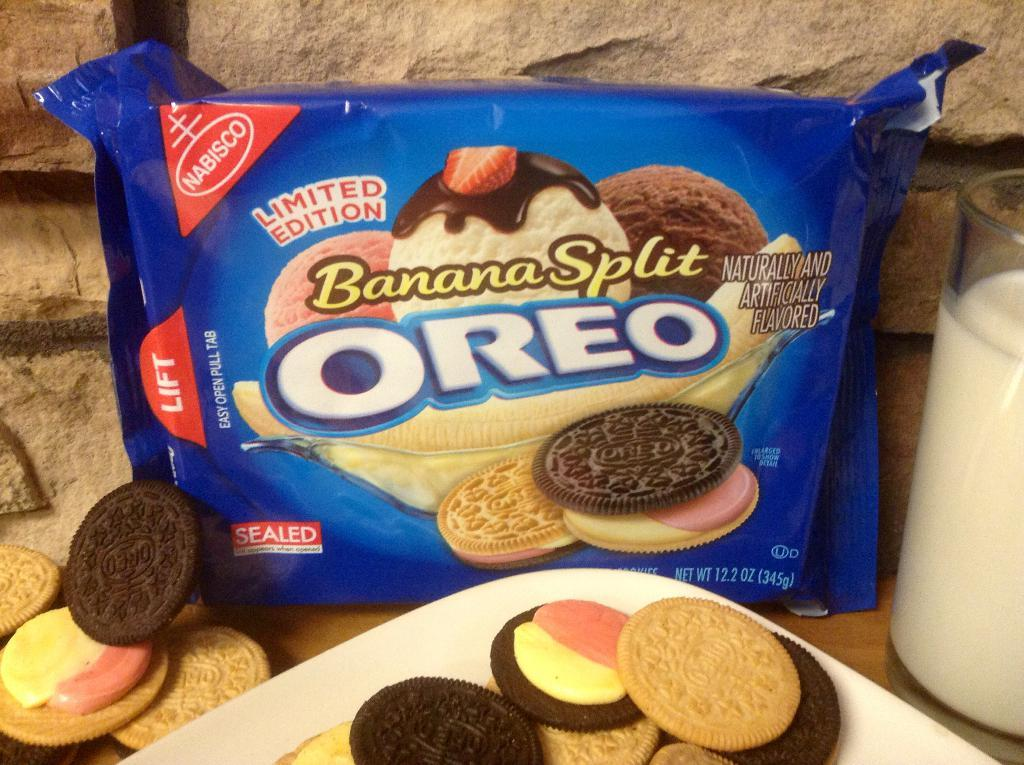What is the main object in the image that has names and images on it? There is a packet with names and images in the image. What type of food can be seen on a plate in the image? There is a plate with biscuits in the image. What can be seen in the background of the image? There is a wall visible in the background of the image. What is in the glass that is visible in the image? There is a glass with milk in the image. Can you tell me how many kites are hanging from the wall in the image? There are no kites present in the image; it features a packet with names and images, a plate with biscuits, a glass with milk, and a wall in the background. Is there a servant in the image assisting with the food and drinks? There is no servant present in the image. 